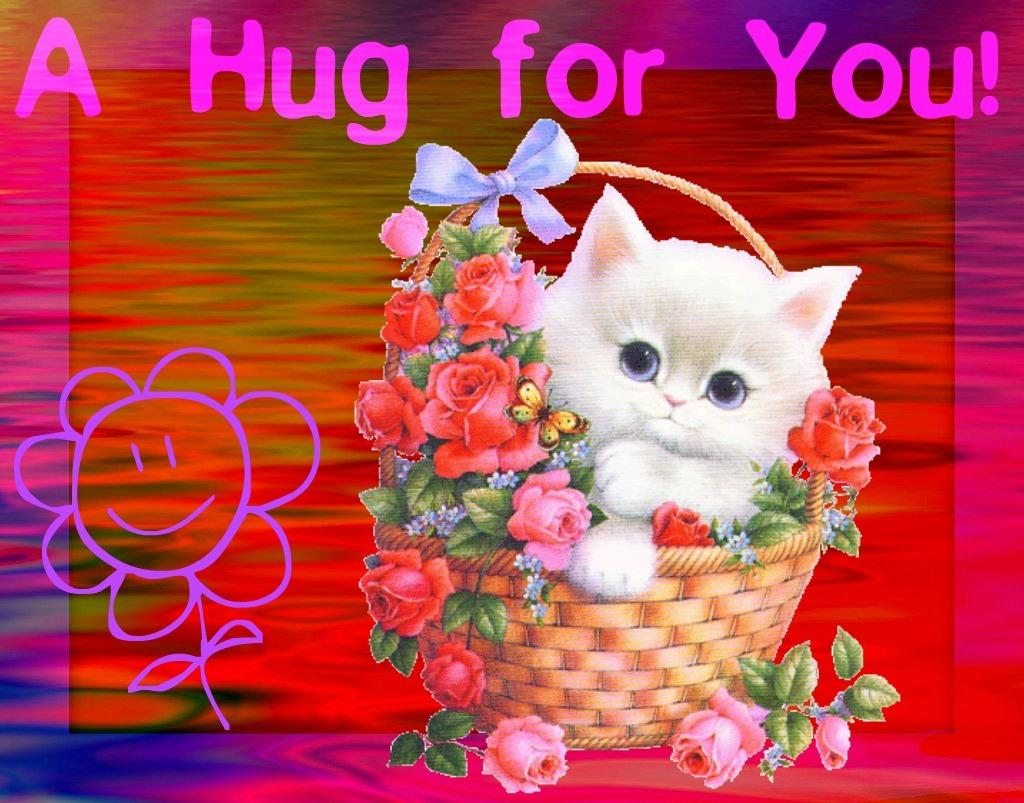What is the main object in the image? There is a flower basket in the image. What is inside the flower basket? The flower basket contains flowers. What other elements can be seen in the image? There are leaves, a butterfly, a cat, and text in the image. How was the image altered? The image has been edited. What type of discovery is being made by the cat in the image? There is no indication of a discovery being made by the cat in the image. Can you see any smoke in the image? There is no smoke present in the image. 